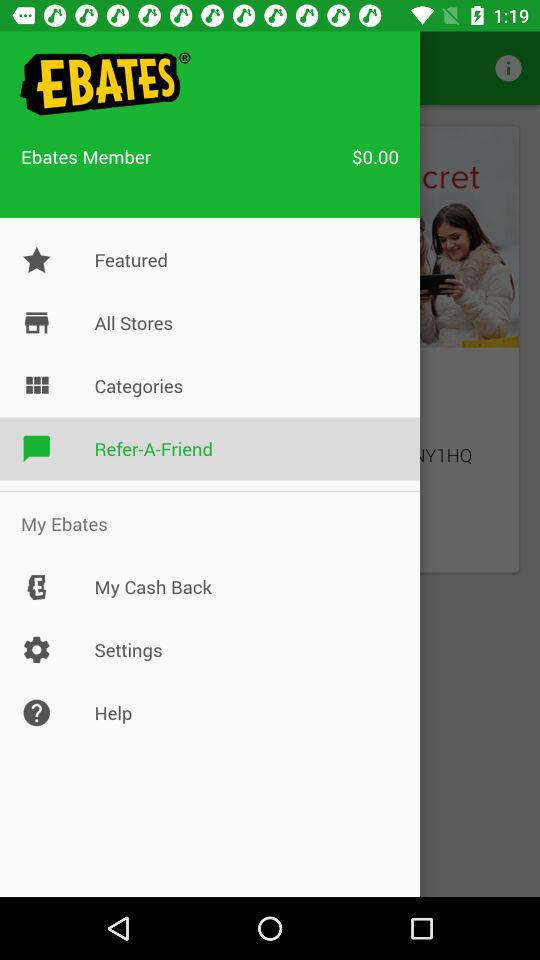How much is the current cash back?
Answer the question using a single word or phrase. $0.00 